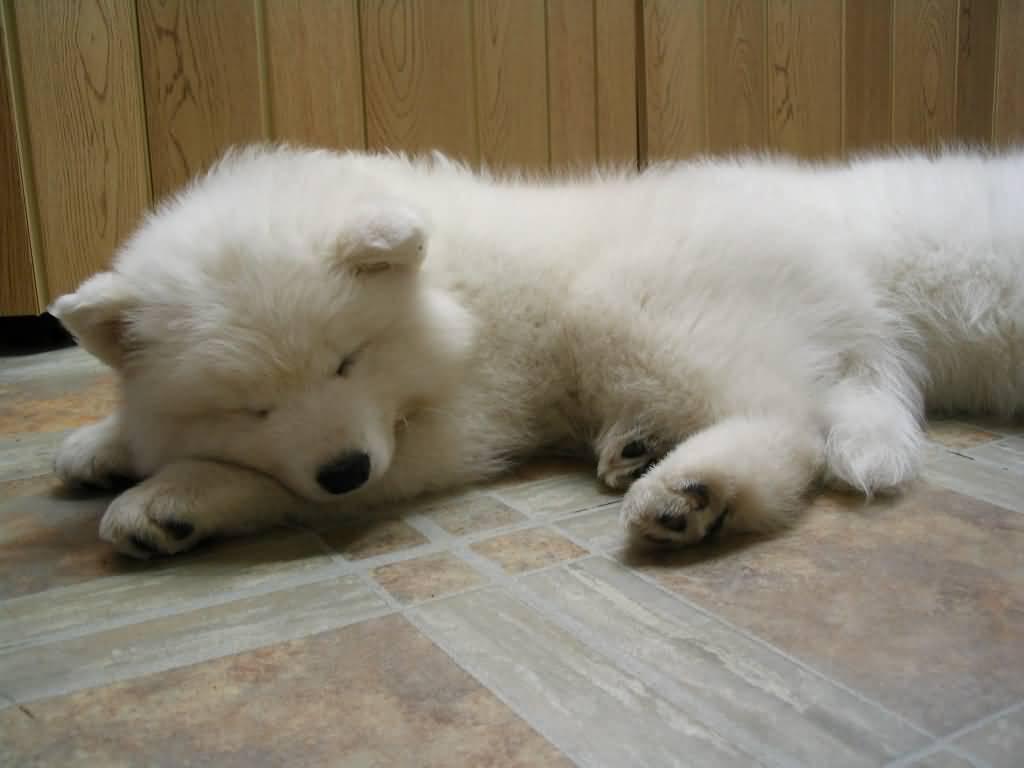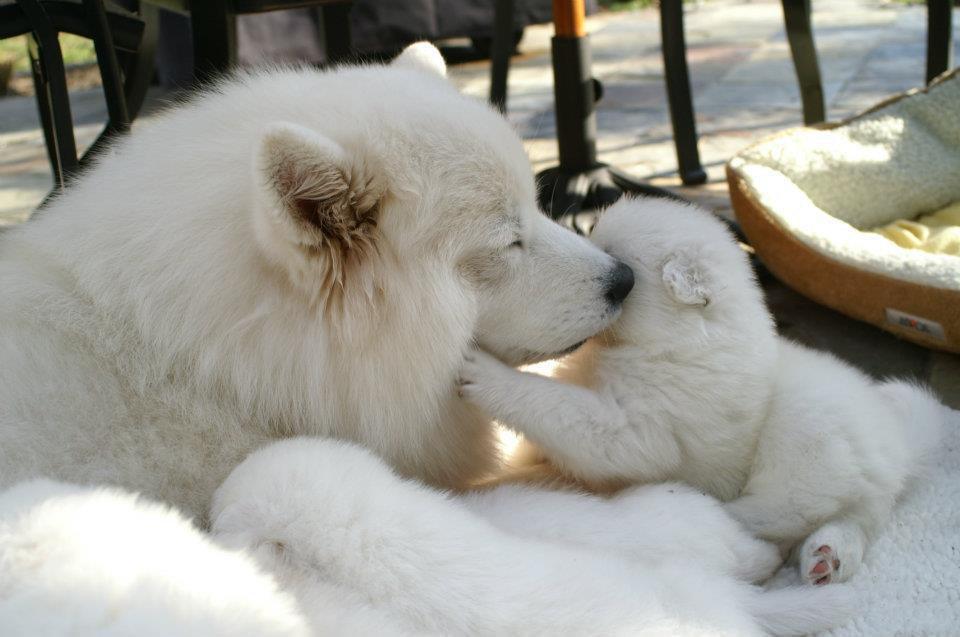The first image is the image on the left, the second image is the image on the right. Examine the images to the left and right. Is the description "The single white dog in the image on the right has its eyes open." accurate? Answer yes or no. No. The first image is the image on the left, the second image is the image on the right. Given the left and right images, does the statement "One image features a reclining white dog with opened eyes." hold true? Answer yes or no. No. 